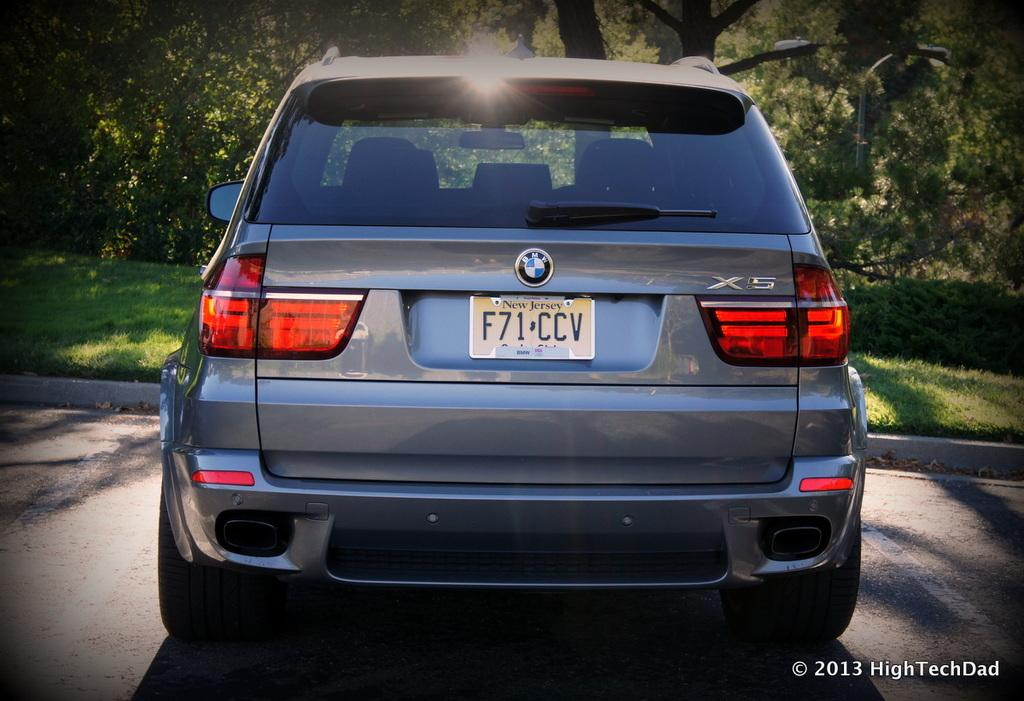What is the main subject of the image? There is a car in the image. Where is the car located? The car is on the road. What can be seen in the background of the image? There are trees and grass in the background of the image. What type of sweater is the car wearing in the image? Cars do not wear sweaters, as they are inanimate objects. 